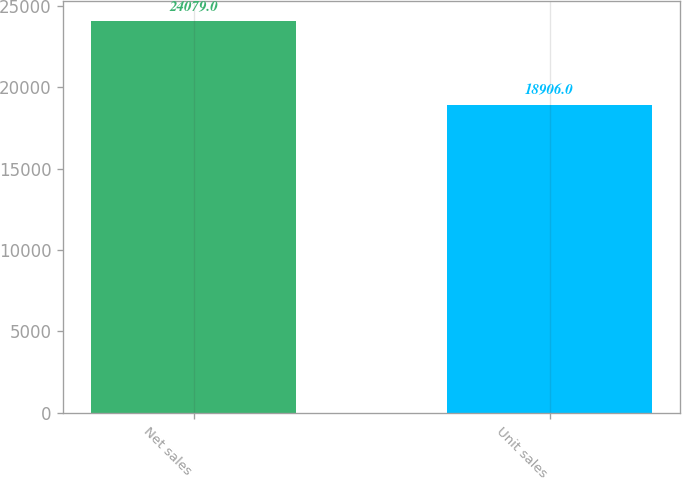Convert chart. <chart><loc_0><loc_0><loc_500><loc_500><bar_chart><fcel>Net sales<fcel>Unit sales<nl><fcel>24079<fcel>18906<nl></chart> 